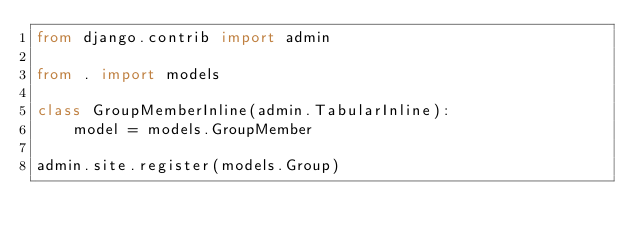<code> <loc_0><loc_0><loc_500><loc_500><_Python_>from django.contrib import admin

from . import models

class GroupMemberInline(admin.TabularInline):
    model = models.GroupMember

admin.site.register(models.Group)
</code> 